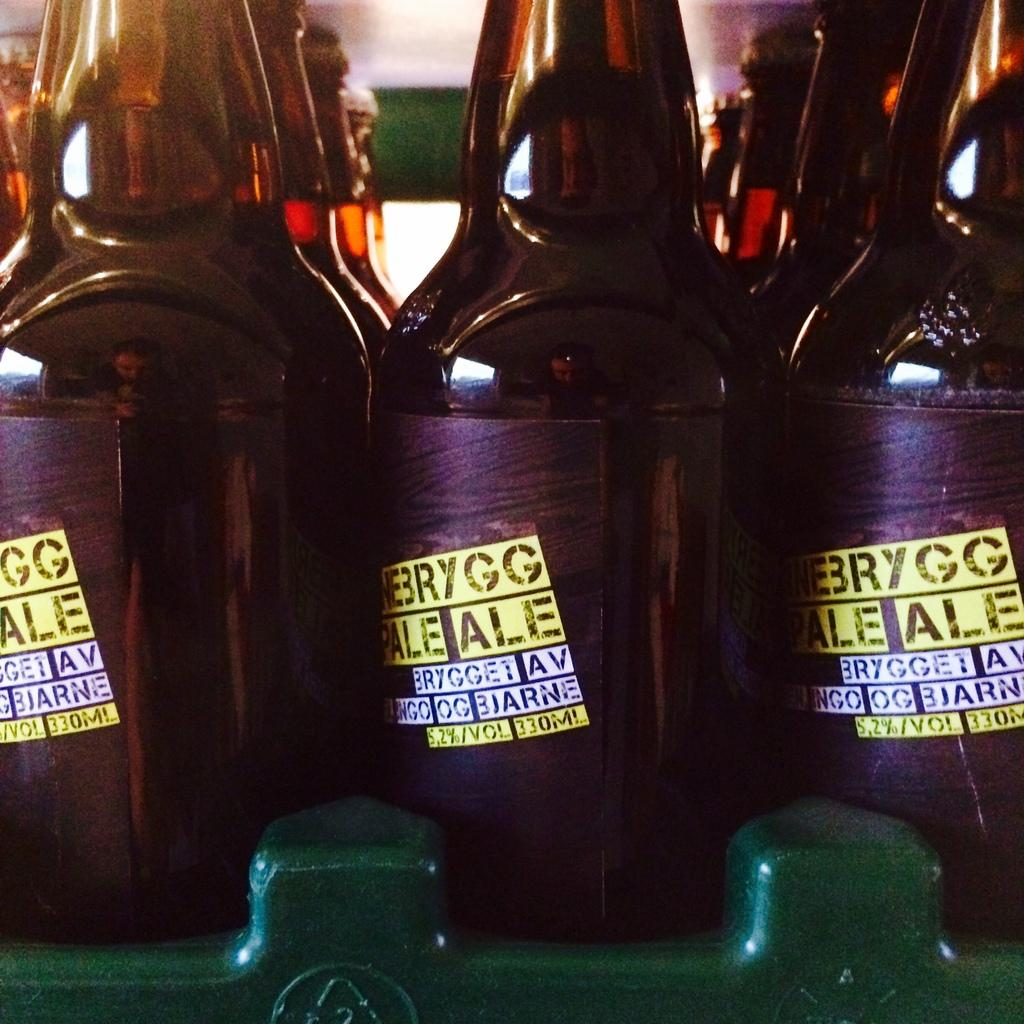How many bottles are visible in the image? There are three bottles in the image. Where are the bottles located in the image? The bottles are in a bottle tray. What is the color of the bottles? The bottles are black in color. What colors are used on the labels of the bottles? The labels on the bottles are white and yellow in color. How does the uncle contribute to pollution in the image? There is no uncle or pollution present in the image; it only features three black bottles with white and yellow labels in a bottle tray. 